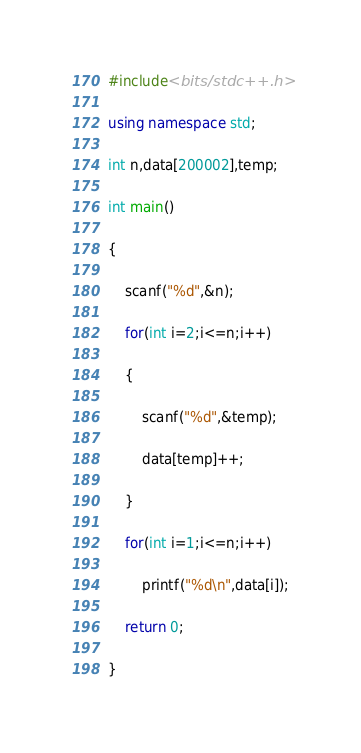<code> <loc_0><loc_0><loc_500><loc_500><_C++_>#include<bits/stdc++.h>

using namespace std;

int n,data[200002],temp;

int main()

{

    scanf("%d",&n);

    for(int i=2;i<=n;i++)

    {

        scanf("%d",&temp);

        data[temp]++;

    }

    for(int i=1;i<=n;i++)

        printf("%d\n",data[i]);

    return 0;

}</code> 